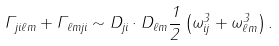<formula> <loc_0><loc_0><loc_500><loc_500>\Gamma _ { j i \ell m } + \Gamma _ { \ell m j i } \sim { D } _ { j i } \cdot { D } _ { \ell m } \frac { 1 } { 2 } \left ( \omega _ { i j } ^ { 3 } + \omega _ { \ell m } ^ { 3 } \right ) .</formula> 